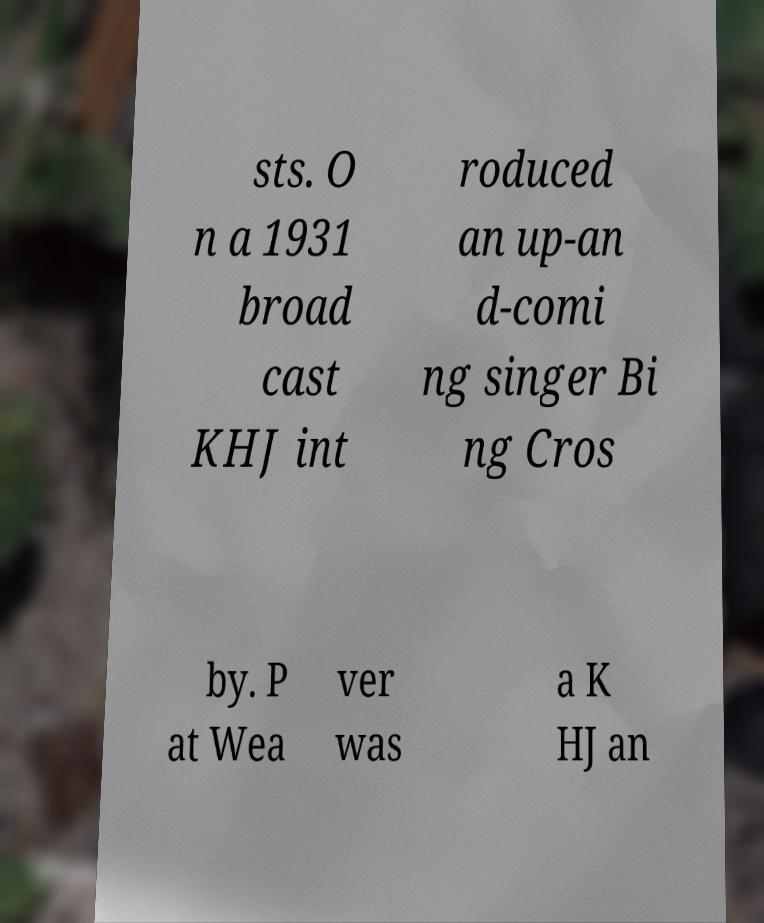What messages or text are displayed in this image? I need them in a readable, typed format. sts. O n a 1931 broad cast KHJ int roduced an up-an d-comi ng singer Bi ng Cros by. P at Wea ver was a K HJ an 